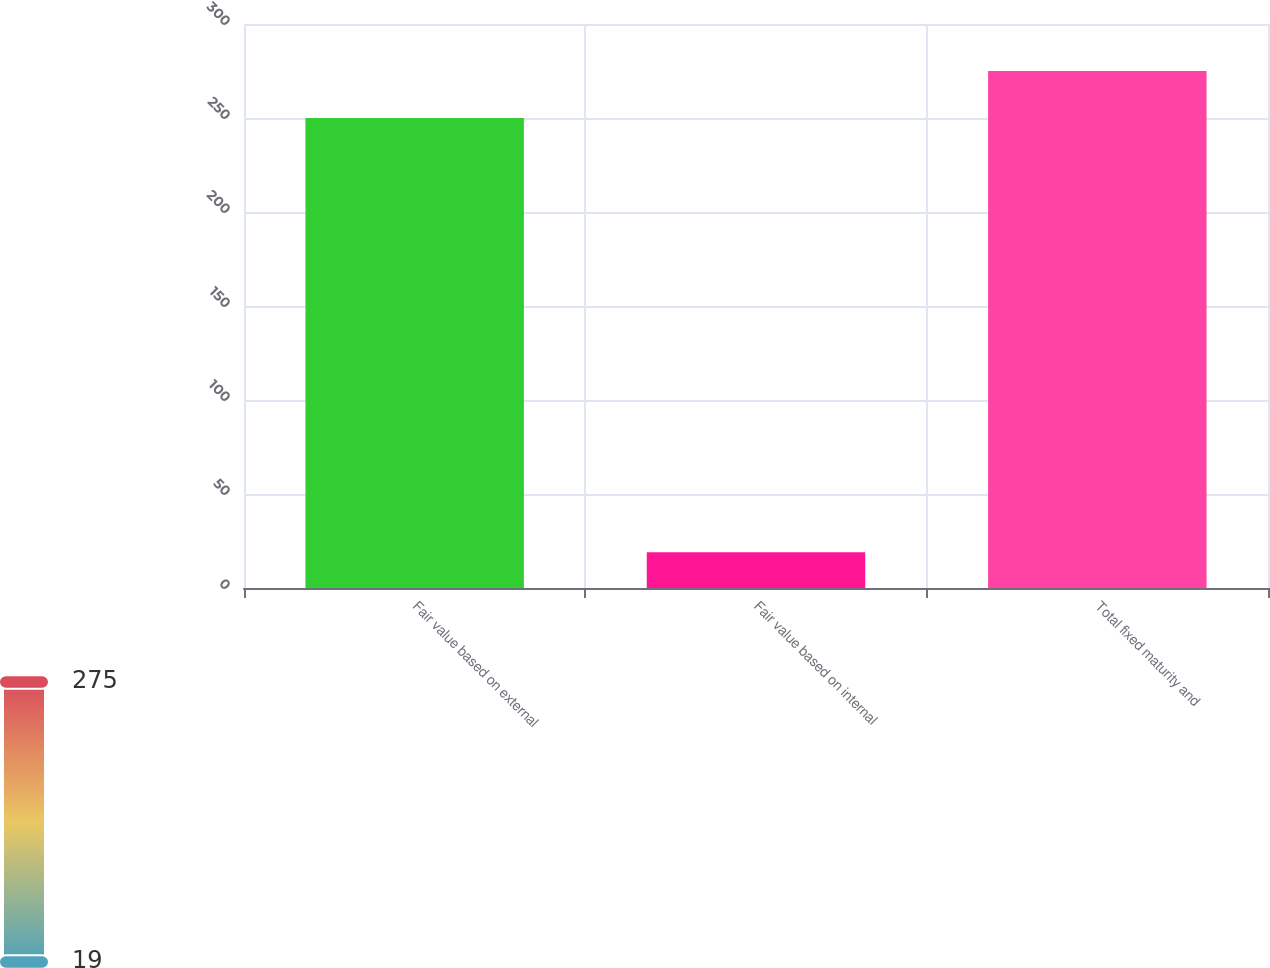<chart> <loc_0><loc_0><loc_500><loc_500><bar_chart><fcel>Fair value based on external<fcel>Fair value based on internal<fcel>Total fixed maturity and<nl><fcel>250<fcel>19<fcel>275<nl></chart> 